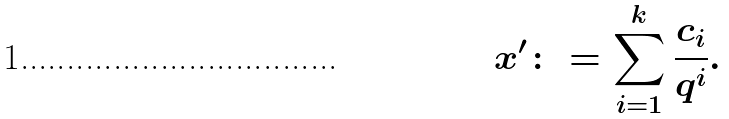<formula> <loc_0><loc_0><loc_500><loc_500>x ^ { \prime } \colon = \sum _ { i = 1 } ^ { k } \frac { c _ { i } } { q ^ { i } } .</formula> 